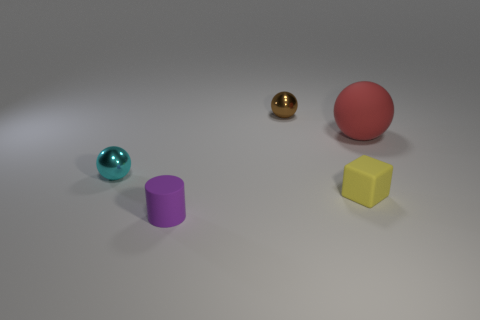There is a ball on the right side of the tiny shiny thing to the right of the small cyan object in front of the big thing; what is its color?
Ensure brevity in your answer.  Red. The large rubber ball has what color?
Your answer should be compact. Red. Do the big ball and the small cylinder have the same color?
Give a very brief answer. No. Do the brown sphere behind the big red rubber object and the object that is to the right of the matte cube have the same material?
Your response must be concise. No. There is a cyan thing that is the same shape as the tiny brown metal thing; what is its material?
Your response must be concise. Metal. Are the large red ball and the small cylinder made of the same material?
Ensure brevity in your answer.  Yes. There is a tiny rubber object on the right side of the rubber thing that is in front of the small yellow matte thing; what color is it?
Ensure brevity in your answer.  Yellow. What is the size of the purple cylinder that is the same material as the large red object?
Keep it short and to the point. Small. What number of yellow rubber objects are the same shape as the red rubber thing?
Offer a very short reply. 0. What number of objects are tiny rubber things on the left side of the small brown metal thing or small metallic things that are right of the small cyan metal sphere?
Provide a succinct answer. 2. 